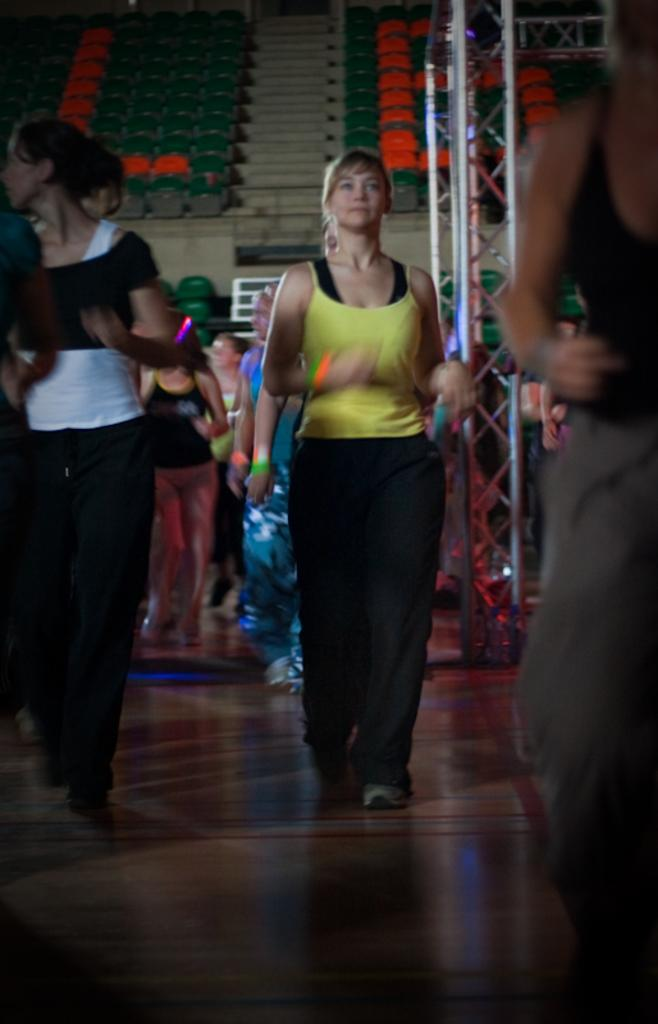What are the people in the image doing? The people in the image are walking. What can be seen in the background of the image? There are chairs and stairs in the background of the image. What is the purpose of the rod visible in the image? The purpose of the rod is not specified in the image. What is at the bottom of the image? There is a floor at the bottom of the image. What type of wound can be seen on the person walking in the image? There is no wound visible on any person in the image. What direction is the zephyr blowing in the image? There is no mention of a zephyr or any wind in the image. 